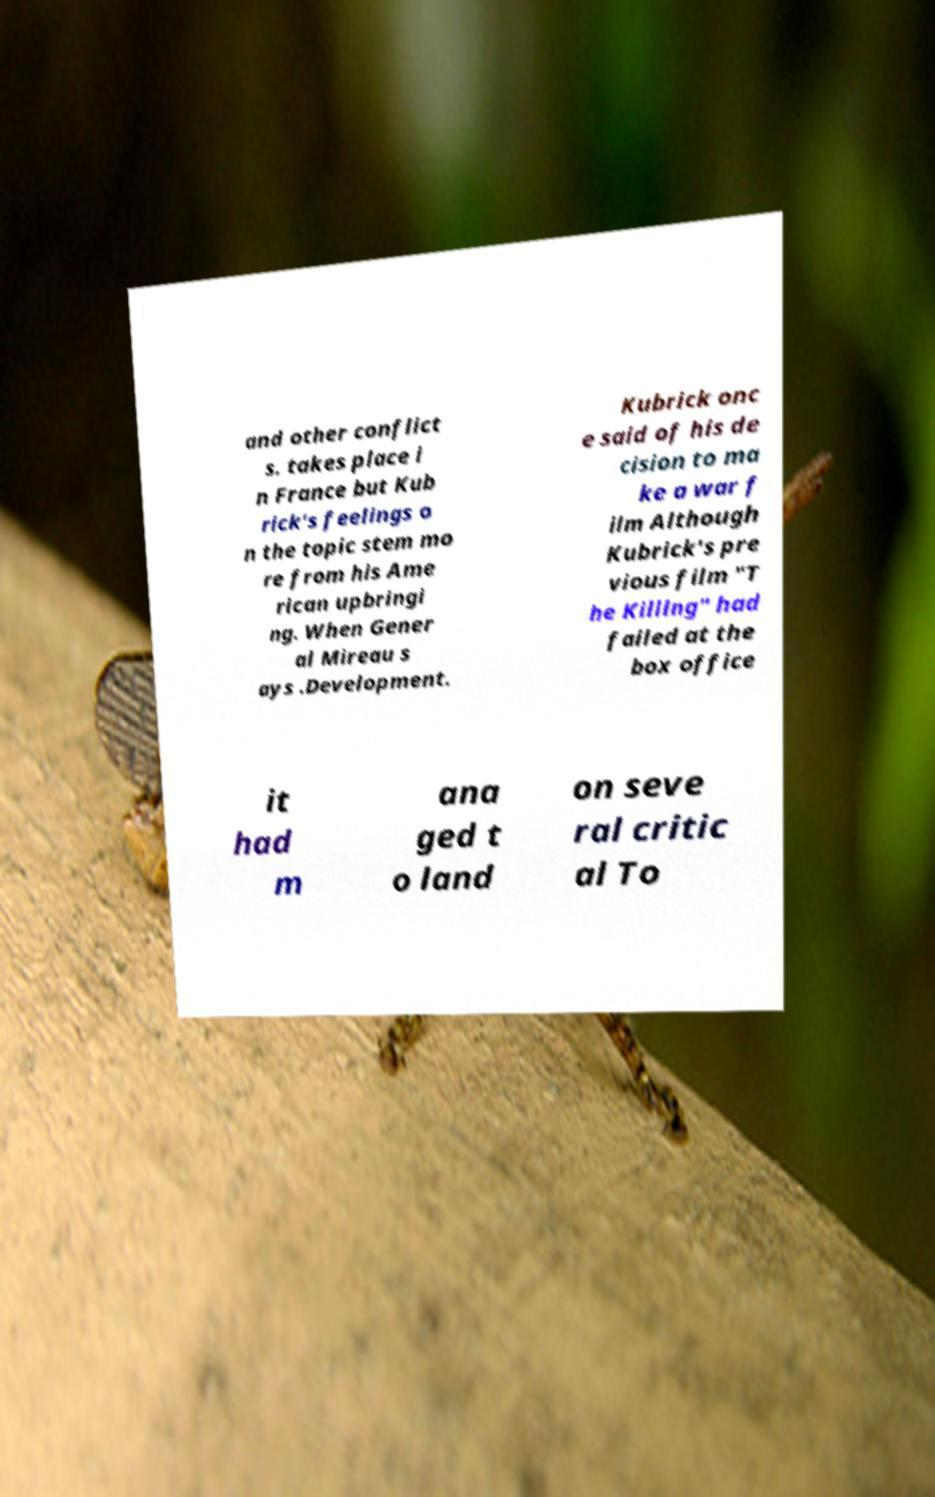Could you extract and type out the text from this image? and other conflict s. takes place i n France but Kub rick's feelings o n the topic stem mo re from his Ame rican upbringi ng. When Gener al Mireau s ays .Development. Kubrick onc e said of his de cision to ma ke a war f ilm Although Kubrick's pre vious film "T he Killing" had failed at the box office it had m ana ged t o land on seve ral critic al To 